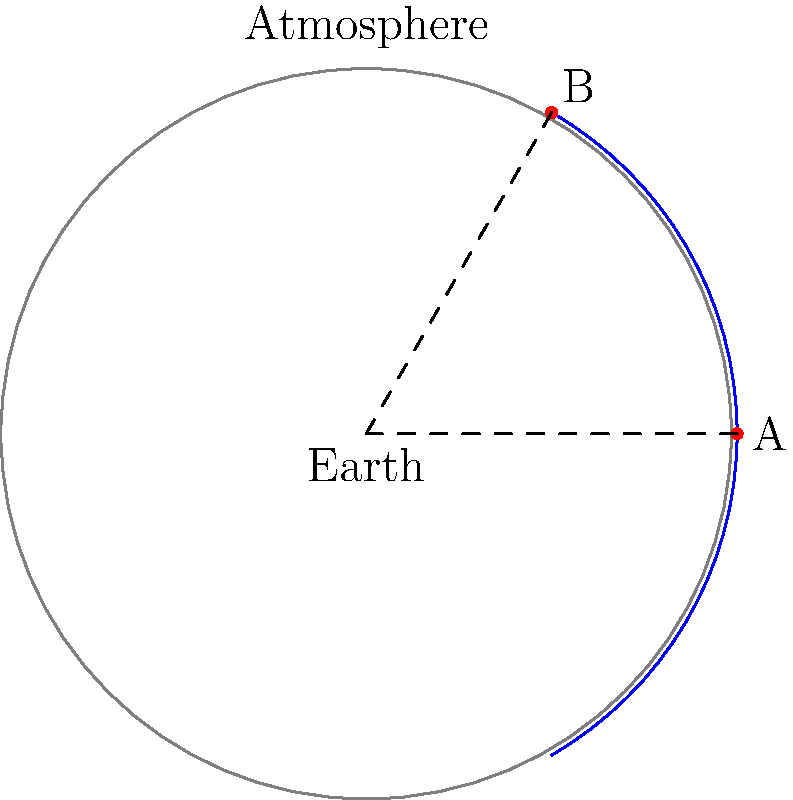In the diagram, the Earth is represented by the gray circle with radius 6371 km, and the blue arc represents the upper boundary of the atmosphere at a height of 100 km. Points A and B are located on this boundary, separated by a central angle of 60°. Calculate the distance between points A and B along the curved surface of the atmosphere. To solve this problem, we'll follow these steps:

1) First, we need to calculate the radius of the arc representing the upper boundary of the atmosphere:
   $R_{atmosphere} = R_{Earth} + h = 6371 \text{ km} + 100 \text{ km} = 6471 \text{ km}$

2) The formula for the length of an arc is:
   $s = R\theta$
   where $s$ is the arc length, $R$ is the radius, and $\theta$ is the central angle in radians.

3) We're given the angle in degrees (60°), so we need to convert it to radians:
   $\theta = 60° \times \frac{\pi}{180°} = \frac{\pi}{3} \text{ radians}$

4) Now we can substitute these values into the arc length formula:
   $s = R_{atmosphere} \times \theta = 6471 \text{ km} \times \frac{\pi}{3}$

5) Calculating this:
   $s = 6471 \times \frac{3.14159}{3} \approx 6775.27 \text{ km}$

Therefore, the distance between points A and B along the curved surface of the atmosphere is approximately 6775.27 km.
Answer: 6775.27 km 